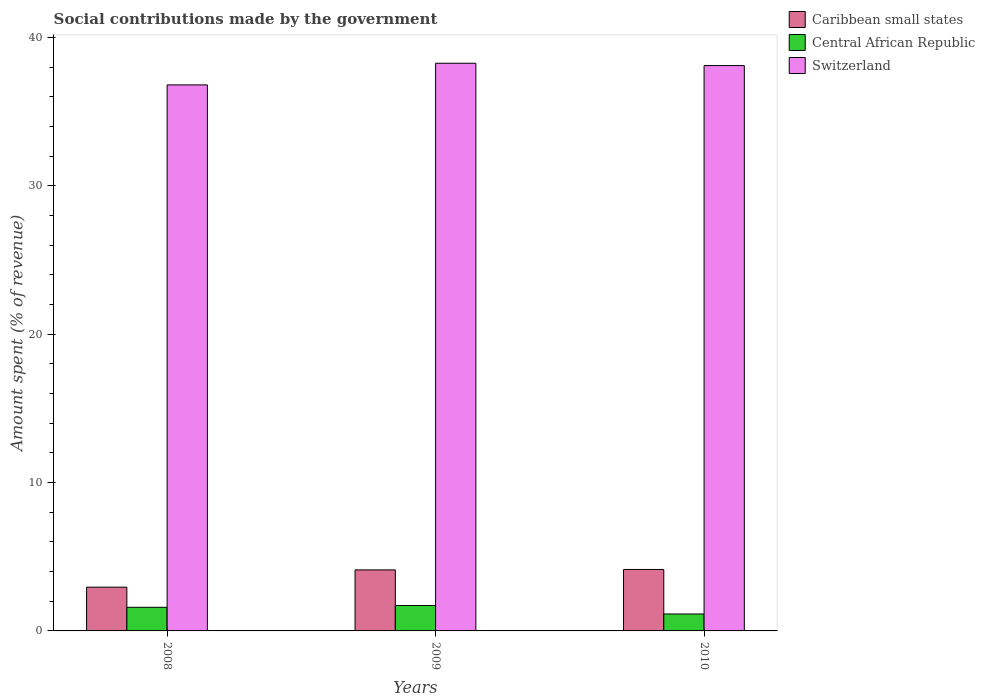In how many cases, is the number of bars for a given year not equal to the number of legend labels?
Offer a terse response. 0. What is the amount spent (in %) on social contributions in Central African Republic in 2009?
Your answer should be very brief. 1.71. Across all years, what is the maximum amount spent (in %) on social contributions in Central African Republic?
Offer a terse response. 1.71. Across all years, what is the minimum amount spent (in %) on social contributions in Switzerland?
Give a very brief answer. 36.8. What is the total amount spent (in %) on social contributions in Switzerland in the graph?
Ensure brevity in your answer.  113.15. What is the difference between the amount spent (in %) on social contributions in Switzerland in 2009 and that in 2010?
Provide a short and direct response. 0.16. What is the difference between the amount spent (in %) on social contributions in Switzerland in 2008 and the amount spent (in %) on social contributions in Central African Republic in 2009?
Keep it short and to the point. 35.08. What is the average amount spent (in %) on social contributions in Switzerland per year?
Your response must be concise. 37.72. In the year 2010, what is the difference between the amount spent (in %) on social contributions in Caribbean small states and amount spent (in %) on social contributions in Central African Republic?
Provide a short and direct response. 3. What is the ratio of the amount spent (in %) on social contributions in Switzerland in 2009 to that in 2010?
Your answer should be very brief. 1. Is the amount spent (in %) on social contributions in Central African Republic in 2008 less than that in 2010?
Offer a very short reply. No. Is the difference between the amount spent (in %) on social contributions in Caribbean small states in 2009 and 2010 greater than the difference between the amount spent (in %) on social contributions in Central African Republic in 2009 and 2010?
Ensure brevity in your answer.  No. What is the difference between the highest and the second highest amount spent (in %) on social contributions in Caribbean small states?
Offer a very short reply. 0.03. What is the difference between the highest and the lowest amount spent (in %) on social contributions in Central African Republic?
Make the answer very short. 0.57. In how many years, is the amount spent (in %) on social contributions in Central African Republic greater than the average amount spent (in %) on social contributions in Central African Republic taken over all years?
Offer a very short reply. 2. What does the 3rd bar from the left in 2010 represents?
Provide a succinct answer. Switzerland. What does the 1st bar from the right in 2008 represents?
Your response must be concise. Switzerland. Is it the case that in every year, the sum of the amount spent (in %) on social contributions in Switzerland and amount spent (in %) on social contributions in Central African Republic is greater than the amount spent (in %) on social contributions in Caribbean small states?
Give a very brief answer. Yes. What is the difference between two consecutive major ticks on the Y-axis?
Give a very brief answer. 10. Does the graph contain any zero values?
Ensure brevity in your answer.  No. Where does the legend appear in the graph?
Provide a succinct answer. Top right. How are the legend labels stacked?
Keep it short and to the point. Vertical. What is the title of the graph?
Your answer should be compact. Social contributions made by the government. What is the label or title of the Y-axis?
Offer a very short reply. Amount spent (% of revenue). What is the Amount spent (% of revenue) of Caribbean small states in 2008?
Give a very brief answer. 2.95. What is the Amount spent (% of revenue) in Central African Republic in 2008?
Your answer should be compact. 1.59. What is the Amount spent (% of revenue) in Switzerland in 2008?
Your answer should be compact. 36.8. What is the Amount spent (% of revenue) in Caribbean small states in 2009?
Your answer should be compact. 4.11. What is the Amount spent (% of revenue) of Central African Republic in 2009?
Offer a very short reply. 1.71. What is the Amount spent (% of revenue) of Switzerland in 2009?
Ensure brevity in your answer.  38.26. What is the Amount spent (% of revenue) in Caribbean small states in 2010?
Keep it short and to the point. 4.14. What is the Amount spent (% of revenue) of Central African Republic in 2010?
Offer a very short reply. 1.14. What is the Amount spent (% of revenue) of Switzerland in 2010?
Make the answer very short. 38.1. Across all years, what is the maximum Amount spent (% of revenue) in Caribbean small states?
Your answer should be compact. 4.14. Across all years, what is the maximum Amount spent (% of revenue) of Central African Republic?
Offer a terse response. 1.71. Across all years, what is the maximum Amount spent (% of revenue) in Switzerland?
Make the answer very short. 38.26. Across all years, what is the minimum Amount spent (% of revenue) of Caribbean small states?
Ensure brevity in your answer.  2.95. Across all years, what is the minimum Amount spent (% of revenue) in Central African Republic?
Provide a short and direct response. 1.14. Across all years, what is the minimum Amount spent (% of revenue) of Switzerland?
Your response must be concise. 36.8. What is the total Amount spent (% of revenue) in Caribbean small states in the graph?
Offer a terse response. 11.2. What is the total Amount spent (% of revenue) in Central African Republic in the graph?
Your answer should be compact. 4.45. What is the total Amount spent (% of revenue) in Switzerland in the graph?
Your response must be concise. 113.15. What is the difference between the Amount spent (% of revenue) in Caribbean small states in 2008 and that in 2009?
Make the answer very short. -1.16. What is the difference between the Amount spent (% of revenue) of Central African Republic in 2008 and that in 2009?
Offer a terse response. -0.12. What is the difference between the Amount spent (% of revenue) in Switzerland in 2008 and that in 2009?
Your response must be concise. -1.46. What is the difference between the Amount spent (% of revenue) in Caribbean small states in 2008 and that in 2010?
Provide a short and direct response. -1.19. What is the difference between the Amount spent (% of revenue) in Central African Republic in 2008 and that in 2010?
Your response must be concise. 0.45. What is the difference between the Amount spent (% of revenue) of Switzerland in 2008 and that in 2010?
Offer a very short reply. -1.3. What is the difference between the Amount spent (% of revenue) in Caribbean small states in 2009 and that in 2010?
Keep it short and to the point. -0.03. What is the difference between the Amount spent (% of revenue) in Central African Republic in 2009 and that in 2010?
Your answer should be compact. 0.57. What is the difference between the Amount spent (% of revenue) in Switzerland in 2009 and that in 2010?
Your answer should be compact. 0.16. What is the difference between the Amount spent (% of revenue) of Caribbean small states in 2008 and the Amount spent (% of revenue) of Central African Republic in 2009?
Give a very brief answer. 1.24. What is the difference between the Amount spent (% of revenue) in Caribbean small states in 2008 and the Amount spent (% of revenue) in Switzerland in 2009?
Your answer should be very brief. -35.31. What is the difference between the Amount spent (% of revenue) in Central African Republic in 2008 and the Amount spent (% of revenue) in Switzerland in 2009?
Provide a succinct answer. -36.66. What is the difference between the Amount spent (% of revenue) of Caribbean small states in 2008 and the Amount spent (% of revenue) of Central African Republic in 2010?
Provide a short and direct response. 1.81. What is the difference between the Amount spent (% of revenue) in Caribbean small states in 2008 and the Amount spent (% of revenue) in Switzerland in 2010?
Offer a terse response. -35.15. What is the difference between the Amount spent (% of revenue) in Central African Republic in 2008 and the Amount spent (% of revenue) in Switzerland in 2010?
Make the answer very short. -36.51. What is the difference between the Amount spent (% of revenue) of Caribbean small states in 2009 and the Amount spent (% of revenue) of Central African Republic in 2010?
Give a very brief answer. 2.97. What is the difference between the Amount spent (% of revenue) in Caribbean small states in 2009 and the Amount spent (% of revenue) in Switzerland in 2010?
Offer a very short reply. -33.99. What is the difference between the Amount spent (% of revenue) of Central African Republic in 2009 and the Amount spent (% of revenue) of Switzerland in 2010?
Provide a succinct answer. -36.39. What is the average Amount spent (% of revenue) in Caribbean small states per year?
Your answer should be compact. 3.73. What is the average Amount spent (% of revenue) of Central African Republic per year?
Your response must be concise. 1.48. What is the average Amount spent (% of revenue) of Switzerland per year?
Keep it short and to the point. 37.72. In the year 2008, what is the difference between the Amount spent (% of revenue) of Caribbean small states and Amount spent (% of revenue) of Central African Republic?
Make the answer very short. 1.36. In the year 2008, what is the difference between the Amount spent (% of revenue) in Caribbean small states and Amount spent (% of revenue) in Switzerland?
Your response must be concise. -33.85. In the year 2008, what is the difference between the Amount spent (% of revenue) in Central African Republic and Amount spent (% of revenue) in Switzerland?
Ensure brevity in your answer.  -35.21. In the year 2009, what is the difference between the Amount spent (% of revenue) in Caribbean small states and Amount spent (% of revenue) in Central African Republic?
Keep it short and to the point. 2.4. In the year 2009, what is the difference between the Amount spent (% of revenue) of Caribbean small states and Amount spent (% of revenue) of Switzerland?
Provide a short and direct response. -34.14. In the year 2009, what is the difference between the Amount spent (% of revenue) of Central African Republic and Amount spent (% of revenue) of Switzerland?
Your answer should be compact. -36.54. In the year 2010, what is the difference between the Amount spent (% of revenue) of Caribbean small states and Amount spent (% of revenue) of Central African Republic?
Offer a terse response. 3. In the year 2010, what is the difference between the Amount spent (% of revenue) of Caribbean small states and Amount spent (% of revenue) of Switzerland?
Your answer should be very brief. -33.96. In the year 2010, what is the difference between the Amount spent (% of revenue) in Central African Republic and Amount spent (% of revenue) in Switzerland?
Offer a terse response. -36.96. What is the ratio of the Amount spent (% of revenue) of Caribbean small states in 2008 to that in 2009?
Your answer should be very brief. 0.72. What is the ratio of the Amount spent (% of revenue) in Central African Republic in 2008 to that in 2009?
Your answer should be compact. 0.93. What is the ratio of the Amount spent (% of revenue) in Switzerland in 2008 to that in 2009?
Provide a short and direct response. 0.96. What is the ratio of the Amount spent (% of revenue) in Caribbean small states in 2008 to that in 2010?
Offer a terse response. 0.71. What is the ratio of the Amount spent (% of revenue) in Central African Republic in 2008 to that in 2010?
Offer a very short reply. 1.39. What is the ratio of the Amount spent (% of revenue) of Switzerland in 2008 to that in 2010?
Offer a terse response. 0.97. What is the ratio of the Amount spent (% of revenue) of Caribbean small states in 2009 to that in 2010?
Provide a succinct answer. 0.99. What is the ratio of the Amount spent (% of revenue) of Central African Republic in 2009 to that in 2010?
Offer a terse response. 1.5. What is the ratio of the Amount spent (% of revenue) of Switzerland in 2009 to that in 2010?
Offer a terse response. 1. What is the difference between the highest and the second highest Amount spent (% of revenue) in Caribbean small states?
Offer a terse response. 0.03. What is the difference between the highest and the second highest Amount spent (% of revenue) in Central African Republic?
Keep it short and to the point. 0.12. What is the difference between the highest and the second highest Amount spent (% of revenue) of Switzerland?
Keep it short and to the point. 0.16. What is the difference between the highest and the lowest Amount spent (% of revenue) of Caribbean small states?
Provide a short and direct response. 1.19. What is the difference between the highest and the lowest Amount spent (% of revenue) of Central African Republic?
Your answer should be very brief. 0.57. What is the difference between the highest and the lowest Amount spent (% of revenue) in Switzerland?
Your answer should be compact. 1.46. 